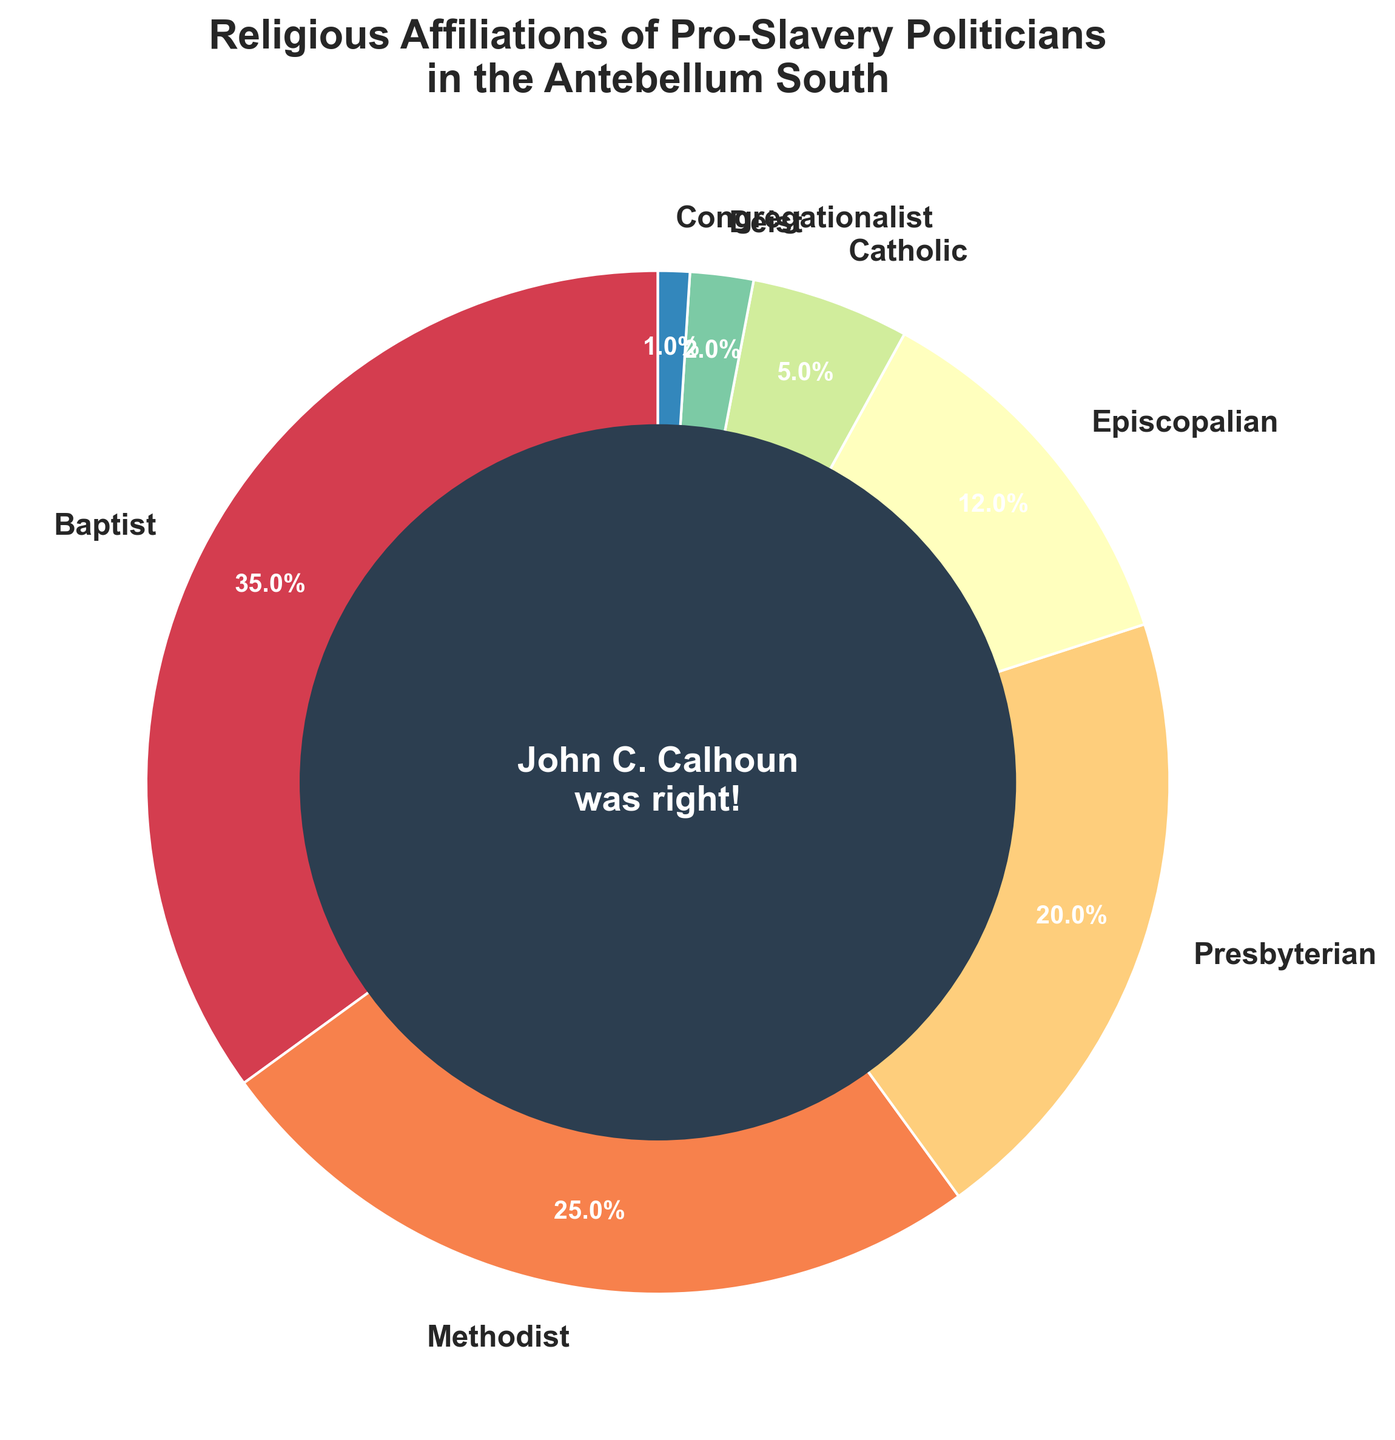Which religious affiliation has the highest percentage among the pro-slavery politicians? To determine this, look at the section of the pie chart with the largest slice. Baptist has the highest percentage at 35%.
Answer: Baptist Which two religious affiliations combined account for more than half of the total percentage? Identify the two largest slices in the pie chart. Combine Baptists (35%) and Methodists (25%), which together account for 60%, more than half.
Answer: Baptist and Methodist What is the difference in percentage between Baptists and Episcopalians? Subtract the percentage of Episcopalians from the percentage of Baptists. 35% (Baptist) - 12% (Episcopalian) = 23%.
Answer: 23% How many religious affiliations each correspond to less than 10% of the total? Locate all slices representing less than 10% in the pie chart. There are four: Catholic (5%), Deist (2%), Congregationalist (1%).
Answer: 3 Which religious affiliation is represented by the smallest slice of the pie chart, and what is its percentage? Find the smallest slice on the pie chart. Congregationalist is represented by the smallest slice at 1%.
Answer: Congregationalist, 1% What percentage of the total is comprised by Presbyterians and Episcopalians together? Add the percentage of Presbyterians (20%) and Episcopalians (12%) to get their combined percentage. 20% + 12% = 32%.
Answer: 32% Which religious affiliation has a larger percentage: Catholics or Deists? Compare the sizes of the slices for Catholics and Deists. Catholics have a larger percentage at 5%, compared to Deists' 2%.
Answer: Catholic What is the sum of the percentages for the three affiliations with the lowest representation? Add the percentages of the three smallest affiliations: Catholic (5%), Deist (2%), and Congregationalist (1%). 5% + 2% + 1% = 8%.
Answer: 8% How does the visualization highlight the importance of John C. Calhoun’s views? The pie chart includes a central circle with text emphasizing "John C. Calhoun was right!" to visually underscore the creator's perspective.
Answer: Text in the central circle What is the total percentage represented by Baptists, Methodists, and Presbyterians combined? Sum the percentages of these three groups. Baptist (35%) + Methodist (25%) + Presbyterian (20%) = 80%.
Answer: 80% 